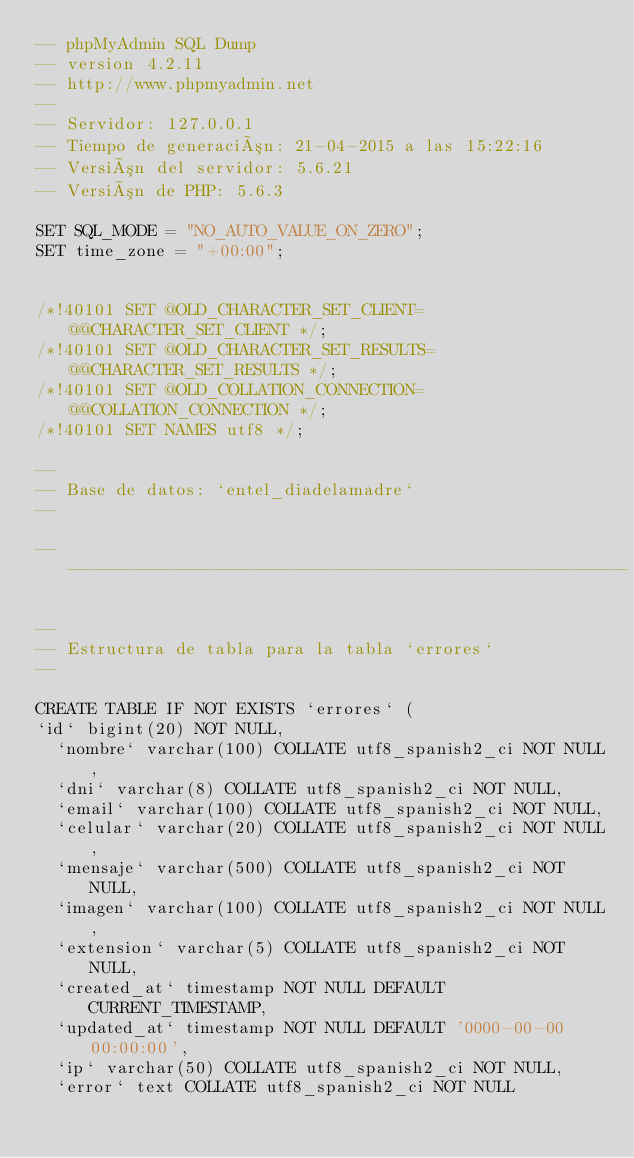<code> <loc_0><loc_0><loc_500><loc_500><_SQL_>-- phpMyAdmin SQL Dump
-- version 4.2.11
-- http://www.phpmyadmin.net
--
-- Servidor: 127.0.0.1
-- Tiempo de generación: 21-04-2015 a las 15:22:16
-- Versión del servidor: 5.6.21
-- Versión de PHP: 5.6.3

SET SQL_MODE = "NO_AUTO_VALUE_ON_ZERO";
SET time_zone = "+00:00";


/*!40101 SET @OLD_CHARACTER_SET_CLIENT=@@CHARACTER_SET_CLIENT */;
/*!40101 SET @OLD_CHARACTER_SET_RESULTS=@@CHARACTER_SET_RESULTS */;
/*!40101 SET @OLD_COLLATION_CONNECTION=@@COLLATION_CONNECTION */;
/*!40101 SET NAMES utf8 */;

--
-- Base de datos: `entel_diadelamadre`
--

-- --------------------------------------------------------

--
-- Estructura de tabla para la tabla `errores`
--

CREATE TABLE IF NOT EXISTS `errores` (
`id` bigint(20) NOT NULL,
  `nombre` varchar(100) COLLATE utf8_spanish2_ci NOT NULL,
  `dni` varchar(8) COLLATE utf8_spanish2_ci NOT NULL,
  `email` varchar(100) COLLATE utf8_spanish2_ci NOT NULL,
  `celular` varchar(20) COLLATE utf8_spanish2_ci NOT NULL,
  `mensaje` varchar(500) COLLATE utf8_spanish2_ci NOT NULL,
  `imagen` varchar(100) COLLATE utf8_spanish2_ci NOT NULL,
  `extension` varchar(5) COLLATE utf8_spanish2_ci NOT NULL,
  `created_at` timestamp NOT NULL DEFAULT CURRENT_TIMESTAMP,
  `updated_at` timestamp NOT NULL DEFAULT '0000-00-00 00:00:00',
  `ip` varchar(50) COLLATE utf8_spanish2_ci NOT NULL,
  `error` text COLLATE utf8_spanish2_ci NOT NULL</code> 